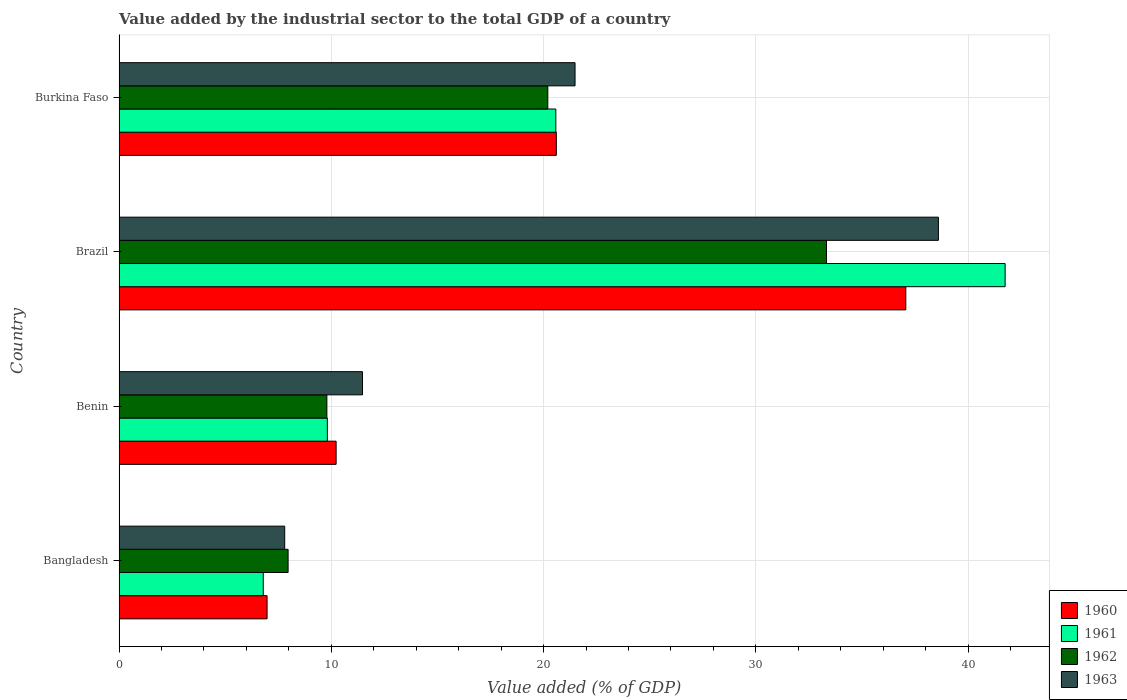How many groups of bars are there?
Make the answer very short. 4. How many bars are there on the 2nd tick from the top?
Give a very brief answer. 4. How many bars are there on the 2nd tick from the bottom?
Keep it short and to the point. 4. What is the label of the 2nd group of bars from the top?
Make the answer very short. Brazil. In how many cases, is the number of bars for a given country not equal to the number of legend labels?
Give a very brief answer. 0. What is the value added by the industrial sector to the total GDP in 1960 in Bangladesh?
Your answer should be compact. 6.97. Across all countries, what is the maximum value added by the industrial sector to the total GDP in 1961?
Your response must be concise. 41.75. Across all countries, what is the minimum value added by the industrial sector to the total GDP in 1961?
Your answer should be very brief. 6.79. In which country was the value added by the industrial sector to the total GDP in 1960 minimum?
Offer a very short reply. Bangladesh. What is the total value added by the industrial sector to the total GDP in 1963 in the graph?
Give a very brief answer. 79.36. What is the difference between the value added by the industrial sector to the total GDP in 1963 in Benin and that in Brazil?
Your response must be concise. -27.13. What is the difference between the value added by the industrial sector to the total GDP in 1961 in Bangladesh and the value added by the industrial sector to the total GDP in 1963 in Burkina Faso?
Make the answer very short. -14.69. What is the average value added by the industrial sector to the total GDP in 1963 per country?
Offer a terse response. 19.84. What is the difference between the value added by the industrial sector to the total GDP in 1962 and value added by the industrial sector to the total GDP in 1961 in Benin?
Provide a short and direct response. -0.02. In how many countries, is the value added by the industrial sector to the total GDP in 1960 greater than 26 %?
Provide a succinct answer. 1. What is the ratio of the value added by the industrial sector to the total GDP in 1963 in Bangladesh to that in Brazil?
Offer a very short reply. 0.2. Is the difference between the value added by the industrial sector to the total GDP in 1962 in Bangladesh and Benin greater than the difference between the value added by the industrial sector to the total GDP in 1961 in Bangladesh and Benin?
Provide a succinct answer. Yes. What is the difference between the highest and the second highest value added by the industrial sector to the total GDP in 1960?
Make the answer very short. 16.47. What is the difference between the highest and the lowest value added by the industrial sector to the total GDP in 1961?
Keep it short and to the point. 34.95. Is the sum of the value added by the industrial sector to the total GDP in 1963 in Bangladesh and Brazil greater than the maximum value added by the industrial sector to the total GDP in 1962 across all countries?
Your response must be concise. Yes. What does the 4th bar from the bottom in Bangladesh represents?
Ensure brevity in your answer.  1963. How many countries are there in the graph?
Give a very brief answer. 4. What is the difference between two consecutive major ticks on the X-axis?
Your response must be concise. 10. Are the values on the major ticks of X-axis written in scientific E-notation?
Keep it short and to the point. No. Does the graph contain any zero values?
Offer a very short reply. No. Where does the legend appear in the graph?
Ensure brevity in your answer.  Bottom right. What is the title of the graph?
Make the answer very short. Value added by the industrial sector to the total GDP of a country. What is the label or title of the X-axis?
Ensure brevity in your answer.  Value added (% of GDP). What is the label or title of the Y-axis?
Ensure brevity in your answer.  Country. What is the Value added (% of GDP) of 1960 in Bangladesh?
Give a very brief answer. 6.97. What is the Value added (% of GDP) in 1961 in Bangladesh?
Your answer should be compact. 6.79. What is the Value added (% of GDP) of 1962 in Bangladesh?
Your response must be concise. 7.96. What is the Value added (% of GDP) of 1963 in Bangladesh?
Give a very brief answer. 7.8. What is the Value added (% of GDP) in 1960 in Benin?
Offer a terse response. 10.23. What is the Value added (% of GDP) of 1961 in Benin?
Your answer should be compact. 9.81. What is the Value added (% of GDP) of 1962 in Benin?
Provide a succinct answer. 9.79. What is the Value added (% of GDP) of 1963 in Benin?
Make the answer very short. 11.47. What is the Value added (% of GDP) of 1960 in Brazil?
Make the answer very short. 37.07. What is the Value added (% of GDP) in 1961 in Brazil?
Your response must be concise. 41.75. What is the Value added (% of GDP) in 1962 in Brazil?
Your answer should be very brief. 33.33. What is the Value added (% of GDP) of 1963 in Brazil?
Your answer should be very brief. 38.6. What is the Value added (% of GDP) in 1960 in Burkina Faso?
Offer a terse response. 20.6. What is the Value added (% of GDP) of 1961 in Burkina Faso?
Provide a succinct answer. 20.58. What is the Value added (% of GDP) of 1962 in Burkina Faso?
Your answer should be compact. 20.2. What is the Value added (% of GDP) in 1963 in Burkina Faso?
Your answer should be compact. 21.48. Across all countries, what is the maximum Value added (% of GDP) of 1960?
Keep it short and to the point. 37.07. Across all countries, what is the maximum Value added (% of GDP) in 1961?
Your answer should be compact. 41.75. Across all countries, what is the maximum Value added (% of GDP) in 1962?
Provide a succinct answer. 33.33. Across all countries, what is the maximum Value added (% of GDP) of 1963?
Offer a very short reply. 38.6. Across all countries, what is the minimum Value added (% of GDP) of 1960?
Your answer should be very brief. 6.97. Across all countries, what is the minimum Value added (% of GDP) in 1961?
Your answer should be compact. 6.79. Across all countries, what is the minimum Value added (% of GDP) in 1962?
Your answer should be compact. 7.96. Across all countries, what is the minimum Value added (% of GDP) of 1963?
Keep it short and to the point. 7.8. What is the total Value added (% of GDP) of 1960 in the graph?
Provide a short and direct response. 74.87. What is the total Value added (% of GDP) of 1961 in the graph?
Keep it short and to the point. 78.93. What is the total Value added (% of GDP) of 1962 in the graph?
Provide a short and direct response. 71.28. What is the total Value added (% of GDP) in 1963 in the graph?
Make the answer very short. 79.36. What is the difference between the Value added (% of GDP) in 1960 in Bangladesh and that in Benin?
Make the answer very short. -3.25. What is the difference between the Value added (% of GDP) of 1961 in Bangladesh and that in Benin?
Ensure brevity in your answer.  -3.02. What is the difference between the Value added (% of GDP) in 1962 in Bangladesh and that in Benin?
Keep it short and to the point. -1.83. What is the difference between the Value added (% of GDP) in 1963 in Bangladesh and that in Benin?
Your response must be concise. -3.66. What is the difference between the Value added (% of GDP) in 1960 in Bangladesh and that in Brazil?
Your answer should be very brief. -30.09. What is the difference between the Value added (% of GDP) of 1961 in Bangladesh and that in Brazil?
Your response must be concise. -34.95. What is the difference between the Value added (% of GDP) in 1962 in Bangladesh and that in Brazil?
Offer a very short reply. -25.37. What is the difference between the Value added (% of GDP) of 1963 in Bangladesh and that in Brazil?
Keep it short and to the point. -30.8. What is the difference between the Value added (% of GDP) in 1960 in Bangladesh and that in Burkina Faso?
Ensure brevity in your answer.  -13.63. What is the difference between the Value added (% of GDP) in 1961 in Bangladesh and that in Burkina Faso?
Offer a terse response. -13.78. What is the difference between the Value added (% of GDP) of 1962 in Bangladesh and that in Burkina Faso?
Ensure brevity in your answer.  -12.24. What is the difference between the Value added (% of GDP) of 1963 in Bangladesh and that in Burkina Faso?
Your answer should be very brief. -13.68. What is the difference between the Value added (% of GDP) of 1960 in Benin and that in Brazil?
Offer a terse response. -26.84. What is the difference between the Value added (% of GDP) in 1961 in Benin and that in Brazil?
Ensure brevity in your answer.  -31.93. What is the difference between the Value added (% of GDP) of 1962 in Benin and that in Brazil?
Your response must be concise. -23.54. What is the difference between the Value added (% of GDP) of 1963 in Benin and that in Brazil?
Offer a terse response. -27.13. What is the difference between the Value added (% of GDP) of 1960 in Benin and that in Burkina Faso?
Keep it short and to the point. -10.37. What is the difference between the Value added (% of GDP) of 1961 in Benin and that in Burkina Faso?
Your answer should be very brief. -10.76. What is the difference between the Value added (% of GDP) of 1962 in Benin and that in Burkina Faso?
Offer a very short reply. -10.41. What is the difference between the Value added (% of GDP) in 1963 in Benin and that in Burkina Faso?
Ensure brevity in your answer.  -10.01. What is the difference between the Value added (% of GDP) in 1960 in Brazil and that in Burkina Faso?
Offer a very short reply. 16.47. What is the difference between the Value added (% of GDP) of 1961 in Brazil and that in Burkina Faso?
Offer a terse response. 21.17. What is the difference between the Value added (% of GDP) in 1962 in Brazil and that in Burkina Faso?
Offer a terse response. 13.13. What is the difference between the Value added (% of GDP) of 1963 in Brazil and that in Burkina Faso?
Offer a terse response. 17.12. What is the difference between the Value added (% of GDP) in 1960 in Bangladesh and the Value added (% of GDP) in 1961 in Benin?
Give a very brief answer. -2.84. What is the difference between the Value added (% of GDP) in 1960 in Bangladesh and the Value added (% of GDP) in 1962 in Benin?
Ensure brevity in your answer.  -2.82. What is the difference between the Value added (% of GDP) of 1960 in Bangladesh and the Value added (% of GDP) of 1963 in Benin?
Provide a succinct answer. -4.5. What is the difference between the Value added (% of GDP) of 1961 in Bangladesh and the Value added (% of GDP) of 1962 in Benin?
Your answer should be very brief. -3. What is the difference between the Value added (% of GDP) of 1961 in Bangladesh and the Value added (% of GDP) of 1963 in Benin?
Your answer should be compact. -4.68. What is the difference between the Value added (% of GDP) of 1962 in Bangladesh and the Value added (% of GDP) of 1963 in Benin?
Your response must be concise. -3.51. What is the difference between the Value added (% of GDP) in 1960 in Bangladesh and the Value added (% of GDP) in 1961 in Brazil?
Offer a very short reply. -34.77. What is the difference between the Value added (% of GDP) in 1960 in Bangladesh and the Value added (% of GDP) in 1962 in Brazil?
Ensure brevity in your answer.  -26.36. What is the difference between the Value added (% of GDP) in 1960 in Bangladesh and the Value added (% of GDP) in 1963 in Brazil?
Your answer should be very brief. -31.63. What is the difference between the Value added (% of GDP) of 1961 in Bangladesh and the Value added (% of GDP) of 1962 in Brazil?
Your answer should be compact. -26.53. What is the difference between the Value added (% of GDP) of 1961 in Bangladesh and the Value added (% of GDP) of 1963 in Brazil?
Offer a terse response. -31.81. What is the difference between the Value added (% of GDP) of 1962 in Bangladesh and the Value added (% of GDP) of 1963 in Brazil?
Ensure brevity in your answer.  -30.64. What is the difference between the Value added (% of GDP) of 1960 in Bangladesh and the Value added (% of GDP) of 1961 in Burkina Faso?
Offer a terse response. -13.6. What is the difference between the Value added (% of GDP) in 1960 in Bangladesh and the Value added (% of GDP) in 1962 in Burkina Faso?
Your answer should be very brief. -13.23. What is the difference between the Value added (% of GDP) in 1960 in Bangladesh and the Value added (% of GDP) in 1963 in Burkina Faso?
Offer a terse response. -14.51. What is the difference between the Value added (% of GDP) in 1961 in Bangladesh and the Value added (% of GDP) in 1962 in Burkina Faso?
Offer a terse response. -13.41. What is the difference between the Value added (% of GDP) of 1961 in Bangladesh and the Value added (% of GDP) of 1963 in Burkina Faso?
Give a very brief answer. -14.69. What is the difference between the Value added (% of GDP) of 1962 in Bangladesh and the Value added (% of GDP) of 1963 in Burkina Faso?
Your answer should be very brief. -13.52. What is the difference between the Value added (% of GDP) of 1960 in Benin and the Value added (% of GDP) of 1961 in Brazil?
Keep it short and to the point. -31.52. What is the difference between the Value added (% of GDP) of 1960 in Benin and the Value added (% of GDP) of 1962 in Brazil?
Offer a terse response. -23.1. What is the difference between the Value added (% of GDP) in 1960 in Benin and the Value added (% of GDP) in 1963 in Brazil?
Your answer should be very brief. -28.37. What is the difference between the Value added (% of GDP) in 1961 in Benin and the Value added (% of GDP) in 1962 in Brazil?
Provide a succinct answer. -23.52. What is the difference between the Value added (% of GDP) in 1961 in Benin and the Value added (% of GDP) in 1963 in Brazil?
Provide a succinct answer. -28.79. What is the difference between the Value added (% of GDP) in 1962 in Benin and the Value added (% of GDP) in 1963 in Brazil?
Offer a very short reply. -28.81. What is the difference between the Value added (% of GDP) in 1960 in Benin and the Value added (% of GDP) in 1961 in Burkina Faso?
Provide a succinct answer. -10.35. What is the difference between the Value added (% of GDP) of 1960 in Benin and the Value added (% of GDP) of 1962 in Burkina Faso?
Ensure brevity in your answer.  -9.97. What is the difference between the Value added (% of GDP) of 1960 in Benin and the Value added (% of GDP) of 1963 in Burkina Faso?
Your answer should be compact. -11.26. What is the difference between the Value added (% of GDP) of 1961 in Benin and the Value added (% of GDP) of 1962 in Burkina Faso?
Give a very brief answer. -10.39. What is the difference between the Value added (% of GDP) in 1961 in Benin and the Value added (% of GDP) in 1963 in Burkina Faso?
Ensure brevity in your answer.  -11.67. What is the difference between the Value added (% of GDP) of 1962 in Benin and the Value added (% of GDP) of 1963 in Burkina Faso?
Offer a very short reply. -11.69. What is the difference between the Value added (% of GDP) of 1960 in Brazil and the Value added (% of GDP) of 1961 in Burkina Faso?
Provide a succinct answer. 16.49. What is the difference between the Value added (% of GDP) in 1960 in Brazil and the Value added (% of GDP) in 1962 in Burkina Faso?
Give a very brief answer. 16.87. What is the difference between the Value added (% of GDP) of 1960 in Brazil and the Value added (% of GDP) of 1963 in Burkina Faso?
Provide a succinct answer. 15.58. What is the difference between the Value added (% of GDP) of 1961 in Brazil and the Value added (% of GDP) of 1962 in Burkina Faso?
Keep it short and to the point. 21.54. What is the difference between the Value added (% of GDP) of 1961 in Brazil and the Value added (% of GDP) of 1963 in Burkina Faso?
Offer a very short reply. 20.26. What is the difference between the Value added (% of GDP) in 1962 in Brazil and the Value added (% of GDP) in 1963 in Burkina Faso?
Give a very brief answer. 11.85. What is the average Value added (% of GDP) of 1960 per country?
Ensure brevity in your answer.  18.72. What is the average Value added (% of GDP) of 1961 per country?
Your answer should be compact. 19.73. What is the average Value added (% of GDP) in 1962 per country?
Your response must be concise. 17.82. What is the average Value added (% of GDP) in 1963 per country?
Give a very brief answer. 19.84. What is the difference between the Value added (% of GDP) of 1960 and Value added (% of GDP) of 1961 in Bangladesh?
Make the answer very short. 0.18. What is the difference between the Value added (% of GDP) of 1960 and Value added (% of GDP) of 1962 in Bangladesh?
Make the answer very short. -0.99. What is the difference between the Value added (% of GDP) of 1960 and Value added (% of GDP) of 1963 in Bangladesh?
Your response must be concise. -0.83. What is the difference between the Value added (% of GDP) in 1961 and Value added (% of GDP) in 1962 in Bangladesh?
Ensure brevity in your answer.  -1.17. What is the difference between the Value added (% of GDP) in 1961 and Value added (% of GDP) in 1963 in Bangladesh?
Your answer should be very brief. -1.01. What is the difference between the Value added (% of GDP) of 1962 and Value added (% of GDP) of 1963 in Bangladesh?
Your answer should be very brief. 0.16. What is the difference between the Value added (% of GDP) in 1960 and Value added (% of GDP) in 1961 in Benin?
Your response must be concise. 0.41. What is the difference between the Value added (% of GDP) of 1960 and Value added (% of GDP) of 1962 in Benin?
Your answer should be compact. 0.44. What is the difference between the Value added (% of GDP) in 1960 and Value added (% of GDP) in 1963 in Benin?
Make the answer very short. -1.24. What is the difference between the Value added (% of GDP) of 1961 and Value added (% of GDP) of 1962 in Benin?
Keep it short and to the point. 0.02. What is the difference between the Value added (% of GDP) of 1961 and Value added (% of GDP) of 1963 in Benin?
Provide a short and direct response. -1.66. What is the difference between the Value added (% of GDP) of 1962 and Value added (% of GDP) of 1963 in Benin?
Your answer should be very brief. -1.68. What is the difference between the Value added (% of GDP) in 1960 and Value added (% of GDP) in 1961 in Brazil?
Offer a very short reply. -4.68. What is the difference between the Value added (% of GDP) in 1960 and Value added (% of GDP) in 1962 in Brazil?
Provide a succinct answer. 3.74. What is the difference between the Value added (% of GDP) of 1960 and Value added (% of GDP) of 1963 in Brazil?
Your answer should be very brief. -1.53. What is the difference between the Value added (% of GDP) in 1961 and Value added (% of GDP) in 1962 in Brazil?
Keep it short and to the point. 8.42. What is the difference between the Value added (% of GDP) of 1961 and Value added (% of GDP) of 1963 in Brazil?
Your answer should be very brief. 3.14. What is the difference between the Value added (% of GDP) of 1962 and Value added (% of GDP) of 1963 in Brazil?
Your answer should be very brief. -5.27. What is the difference between the Value added (% of GDP) in 1960 and Value added (% of GDP) in 1961 in Burkina Faso?
Provide a succinct answer. 0.02. What is the difference between the Value added (% of GDP) in 1960 and Value added (% of GDP) in 1962 in Burkina Faso?
Your response must be concise. 0.4. What is the difference between the Value added (% of GDP) of 1960 and Value added (% of GDP) of 1963 in Burkina Faso?
Your response must be concise. -0.88. What is the difference between the Value added (% of GDP) of 1961 and Value added (% of GDP) of 1962 in Burkina Faso?
Ensure brevity in your answer.  0.38. What is the difference between the Value added (% of GDP) in 1961 and Value added (% of GDP) in 1963 in Burkina Faso?
Provide a succinct answer. -0.91. What is the difference between the Value added (% of GDP) in 1962 and Value added (% of GDP) in 1963 in Burkina Faso?
Make the answer very short. -1.28. What is the ratio of the Value added (% of GDP) in 1960 in Bangladesh to that in Benin?
Give a very brief answer. 0.68. What is the ratio of the Value added (% of GDP) of 1961 in Bangladesh to that in Benin?
Provide a succinct answer. 0.69. What is the ratio of the Value added (% of GDP) of 1962 in Bangladesh to that in Benin?
Your answer should be very brief. 0.81. What is the ratio of the Value added (% of GDP) of 1963 in Bangladesh to that in Benin?
Your answer should be very brief. 0.68. What is the ratio of the Value added (% of GDP) of 1960 in Bangladesh to that in Brazil?
Keep it short and to the point. 0.19. What is the ratio of the Value added (% of GDP) in 1961 in Bangladesh to that in Brazil?
Ensure brevity in your answer.  0.16. What is the ratio of the Value added (% of GDP) of 1962 in Bangladesh to that in Brazil?
Make the answer very short. 0.24. What is the ratio of the Value added (% of GDP) of 1963 in Bangladesh to that in Brazil?
Your answer should be very brief. 0.2. What is the ratio of the Value added (% of GDP) of 1960 in Bangladesh to that in Burkina Faso?
Ensure brevity in your answer.  0.34. What is the ratio of the Value added (% of GDP) in 1961 in Bangladesh to that in Burkina Faso?
Your response must be concise. 0.33. What is the ratio of the Value added (% of GDP) in 1962 in Bangladesh to that in Burkina Faso?
Give a very brief answer. 0.39. What is the ratio of the Value added (% of GDP) in 1963 in Bangladesh to that in Burkina Faso?
Provide a succinct answer. 0.36. What is the ratio of the Value added (% of GDP) in 1960 in Benin to that in Brazil?
Keep it short and to the point. 0.28. What is the ratio of the Value added (% of GDP) in 1961 in Benin to that in Brazil?
Provide a short and direct response. 0.24. What is the ratio of the Value added (% of GDP) of 1962 in Benin to that in Brazil?
Provide a short and direct response. 0.29. What is the ratio of the Value added (% of GDP) in 1963 in Benin to that in Brazil?
Provide a succinct answer. 0.3. What is the ratio of the Value added (% of GDP) in 1960 in Benin to that in Burkina Faso?
Keep it short and to the point. 0.5. What is the ratio of the Value added (% of GDP) in 1961 in Benin to that in Burkina Faso?
Make the answer very short. 0.48. What is the ratio of the Value added (% of GDP) in 1962 in Benin to that in Burkina Faso?
Offer a terse response. 0.48. What is the ratio of the Value added (% of GDP) in 1963 in Benin to that in Burkina Faso?
Offer a terse response. 0.53. What is the ratio of the Value added (% of GDP) of 1960 in Brazil to that in Burkina Faso?
Provide a short and direct response. 1.8. What is the ratio of the Value added (% of GDP) of 1961 in Brazil to that in Burkina Faso?
Provide a short and direct response. 2.03. What is the ratio of the Value added (% of GDP) of 1962 in Brazil to that in Burkina Faso?
Keep it short and to the point. 1.65. What is the ratio of the Value added (% of GDP) in 1963 in Brazil to that in Burkina Faso?
Give a very brief answer. 1.8. What is the difference between the highest and the second highest Value added (% of GDP) in 1960?
Provide a short and direct response. 16.47. What is the difference between the highest and the second highest Value added (% of GDP) of 1961?
Provide a succinct answer. 21.17. What is the difference between the highest and the second highest Value added (% of GDP) in 1962?
Provide a succinct answer. 13.13. What is the difference between the highest and the second highest Value added (% of GDP) in 1963?
Give a very brief answer. 17.12. What is the difference between the highest and the lowest Value added (% of GDP) of 1960?
Make the answer very short. 30.09. What is the difference between the highest and the lowest Value added (% of GDP) in 1961?
Give a very brief answer. 34.95. What is the difference between the highest and the lowest Value added (% of GDP) in 1962?
Your answer should be very brief. 25.37. What is the difference between the highest and the lowest Value added (% of GDP) in 1963?
Provide a succinct answer. 30.8. 